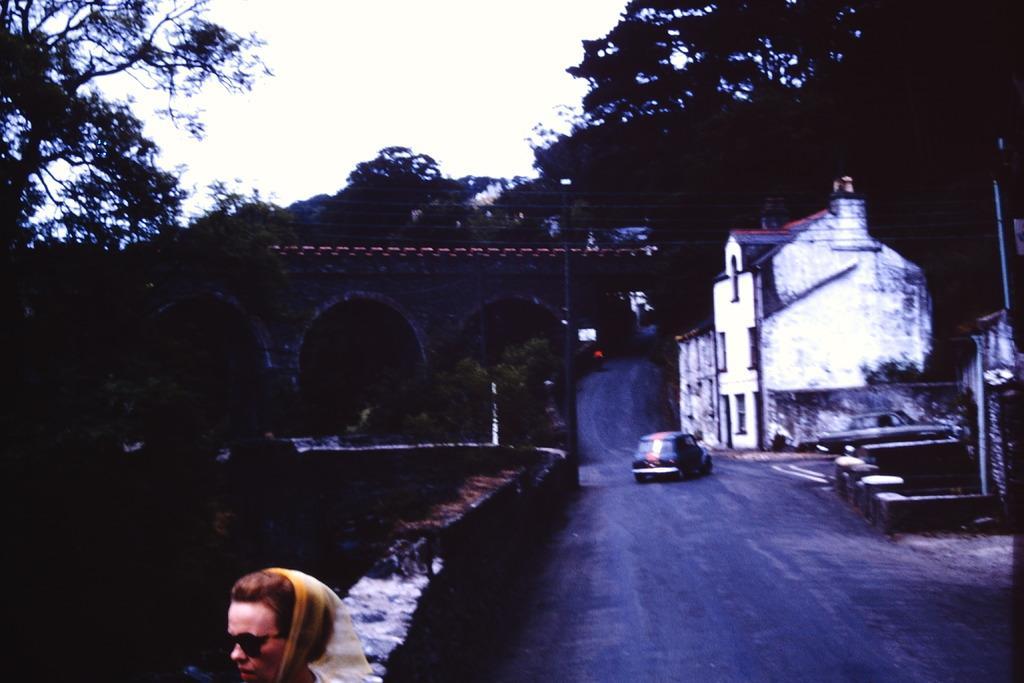Can you describe this image briefly? This picture shows trees and we see buildings and a car on the road and we see a woman, she wore sunglasses and we see a cloudy sky. 